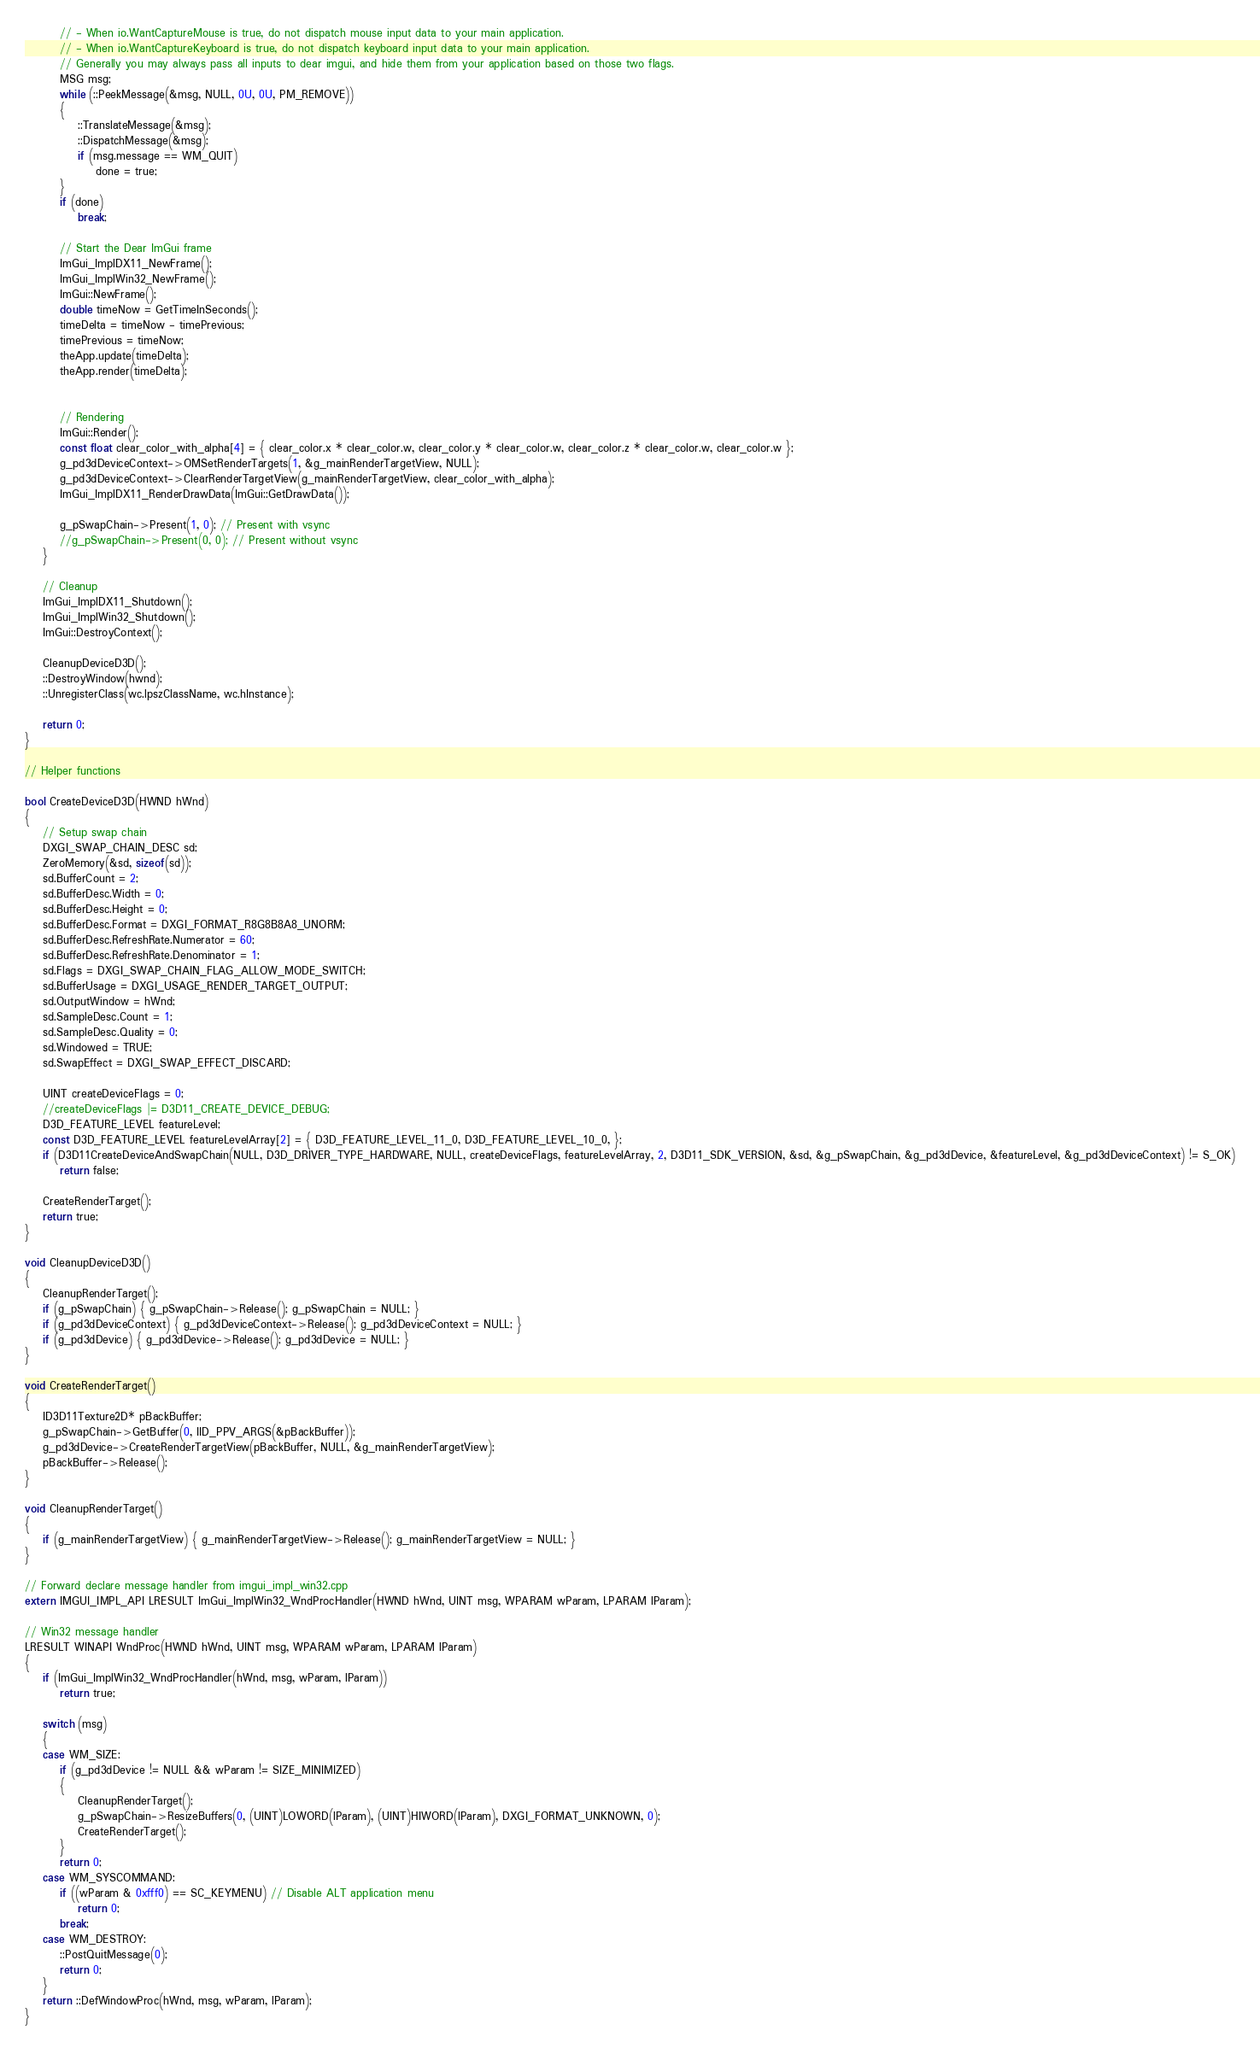<code> <loc_0><loc_0><loc_500><loc_500><_C++_>        // - When io.WantCaptureMouse is true, do not dispatch mouse input data to your main application.
        // - When io.WantCaptureKeyboard is true, do not dispatch keyboard input data to your main application.
        // Generally you may always pass all inputs to dear imgui, and hide them from your application based on those two flags.
        MSG msg;
        while (::PeekMessage(&msg, NULL, 0U, 0U, PM_REMOVE))
        {
            ::TranslateMessage(&msg);
            ::DispatchMessage(&msg);
            if (msg.message == WM_QUIT)
                done = true;
        }
        if (done)
            break;

        // Start the Dear ImGui frame
        ImGui_ImplDX11_NewFrame();
        ImGui_ImplWin32_NewFrame();
        ImGui::NewFrame();
        double timeNow = GetTimeInSeconds();
        timeDelta = timeNow - timePrevious;
        timePrevious = timeNow;
        theApp.update(timeDelta);
        theApp.render(timeDelta);


        // Rendering
        ImGui::Render();
        const float clear_color_with_alpha[4] = { clear_color.x * clear_color.w, clear_color.y * clear_color.w, clear_color.z * clear_color.w, clear_color.w };
        g_pd3dDeviceContext->OMSetRenderTargets(1, &g_mainRenderTargetView, NULL);
        g_pd3dDeviceContext->ClearRenderTargetView(g_mainRenderTargetView, clear_color_with_alpha);
        ImGui_ImplDX11_RenderDrawData(ImGui::GetDrawData());

        g_pSwapChain->Present(1, 0); // Present with vsync
        //g_pSwapChain->Present(0, 0); // Present without vsync
    }

    // Cleanup
    ImGui_ImplDX11_Shutdown();
    ImGui_ImplWin32_Shutdown();
    ImGui::DestroyContext();

    CleanupDeviceD3D();
    ::DestroyWindow(hwnd);
    ::UnregisterClass(wc.lpszClassName, wc.hInstance);

    return 0;
}

// Helper functions

bool CreateDeviceD3D(HWND hWnd)
{
    // Setup swap chain
    DXGI_SWAP_CHAIN_DESC sd;
    ZeroMemory(&sd, sizeof(sd));
    sd.BufferCount = 2;
    sd.BufferDesc.Width = 0;
    sd.BufferDesc.Height = 0;
    sd.BufferDesc.Format = DXGI_FORMAT_R8G8B8A8_UNORM;
    sd.BufferDesc.RefreshRate.Numerator = 60;
    sd.BufferDesc.RefreshRate.Denominator = 1;
    sd.Flags = DXGI_SWAP_CHAIN_FLAG_ALLOW_MODE_SWITCH;
    sd.BufferUsage = DXGI_USAGE_RENDER_TARGET_OUTPUT;
    sd.OutputWindow = hWnd;
    sd.SampleDesc.Count = 1;
    sd.SampleDesc.Quality = 0;
    sd.Windowed = TRUE;
    sd.SwapEffect = DXGI_SWAP_EFFECT_DISCARD;

    UINT createDeviceFlags = 0;
    //createDeviceFlags |= D3D11_CREATE_DEVICE_DEBUG;
    D3D_FEATURE_LEVEL featureLevel;
    const D3D_FEATURE_LEVEL featureLevelArray[2] = { D3D_FEATURE_LEVEL_11_0, D3D_FEATURE_LEVEL_10_0, };
    if (D3D11CreateDeviceAndSwapChain(NULL, D3D_DRIVER_TYPE_HARDWARE, NULL, createDeviceFlags, featureLevelArray, 2, D3D11_SDK_VERSION, &sd, &g_pSwapChain, &g_pd3dDevice, &featureLevel, &g_pd3dDeviceContext) != S_OK)
        return false;

    CreateRenderTarget();
    return true;
}

void CleanupDeviceD3D()
{
    CleanupRenderTarget();
    if (g_pSwapChain) { g_pSwapChain->Release(); g_pSwapChain = NULL; }
    if (g_pd3dDeviceContext) { g_pd3dDeviceContext->Release(); g_pd3dDeviceContext = NULL; }
    if (g_pd3dDevice) { g_pd3dDevice->Release(); g_pd3dDevice = NULL; }
}

void CreateRenderTarget()
{
    ID3D11Texture2D* pBackBuffer;
    g_pSwapChain->GetBuffer(0, IID_PPV_ARGS(&pBackBuffer));
    g_pd3dDevice->CreateRenderTargetView(pBackBuffer, NULL, &g_mainRenderTargetView);
    pBackBuffer->Release();
}

void CleanupRenderTarget()
{
    if (g_mainRenderTargetView) { g_mainRenderTargetView->Release(); g_mainRenderTargetView = NULL; }
}

// Forward declare message handler from imgui_impl_win32.cpp
extern IMGUI_IMPL_API LRESULT ImGui_ImplWin32_WndProcHandler(HWND hWnd, UINT msg, WPARAM wParam, LPARAM lParam);

// Win32 message handler
LRESULT WINAPI WndProc(HWND hWnd, UINT msg, WPARAM wParam, LPARAM lParam)
{
    if (ImGui_ImplWin32_WndProcHandler(hWnd, msg, wParam, lParam))
        return true;

    switch (msg)
    {
    case WM_SIZE:
        if (g_pd3dDevice != NULL && wParam != SIZE_MINIMIZED)
        {
            CleanupRenderTarget();
            g_pSwapChain->ResizeBuffers(0, (UINT)LOWORD(lParam), (UINT)HIWORD(lParam), DXGI_FORMAT_UNKNOWN, 0);
            CreateRenderTarget();
        }
        return 0;
    case WM_SYSCOMMAND:
        if ((wParam & 0xfff0) == SC_KEYMENU) // Disable ALT application menu
            return 0;
        break;
    case WM_DESTROY:
        ::PostQuitMessage(0);
        return 0;
    }
    return ::DefWindowProc(hWnd, msg, wParam, lParam);
}
</code> 